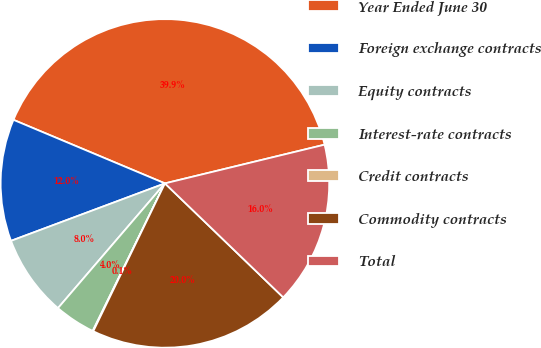<chart> <loc_0><loc_0><loc_500><loc_500><pie_chart><fcel>Year Ended June 30<fcel>Foreign exchange contracts<fcel>Equity contracts<fcel>Interest-rate contracts<fcel>Credit contracts<fcel>Commodity contracts<fcel>Total<nl><fcel>39.89%<fcel>12.01%<fcel>8.03%<fcel>4.04%<fcel>0.06%<fcel>19.98%<fcel>15.99%<nl></chart> 